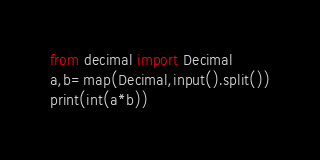Convert code to text. <code><loc_0><loc_0><loc_500><loc_500><_Python_>from decimal import Decimal
a,b=map(Decimal,input().split())
print(int(a*b))</code> 